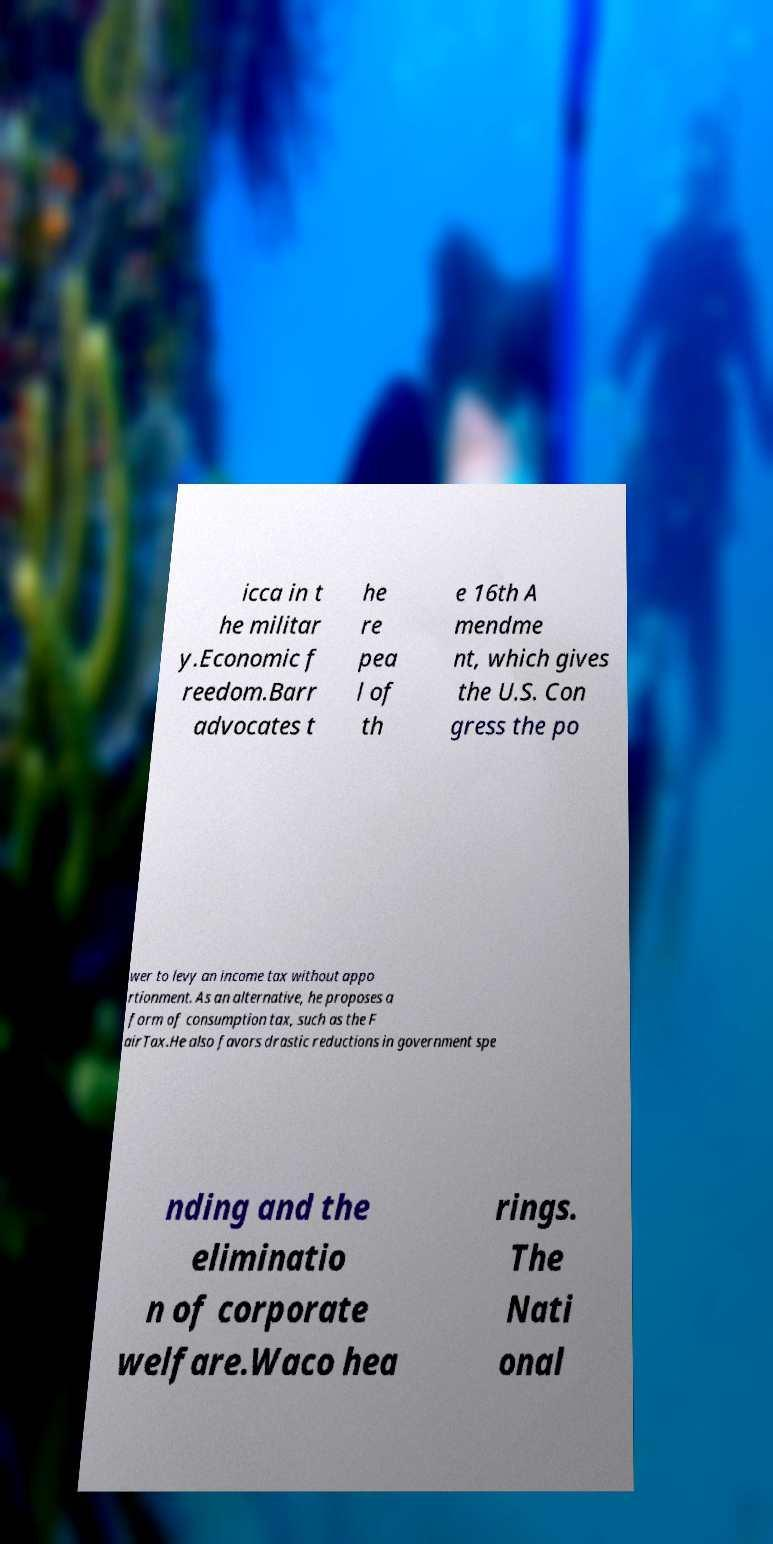I need the written content from this picture converted into text. Can you do that? icca in t he militar y.Economic f reedom.Barr advocates t he re pea l of th e 16th A mendme nt, which gives the U.S. Con gress the po wer to levy an income tax without appo rtionment. As an alternative, he proposes a form of consumption tax, such as the F airTax.He also favors drastic reductions in government spe nding and the eliminatio n of corporate welfare.Waco hea rings. The Nati onal 